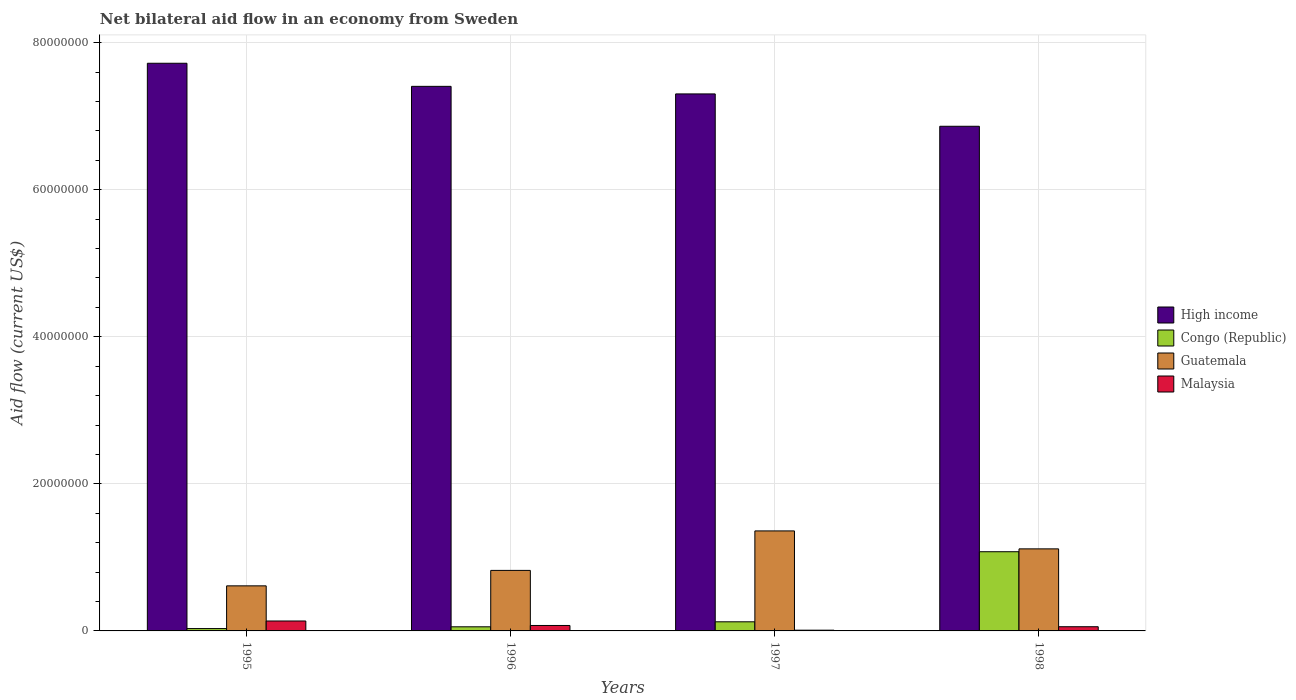Are the number of bars per tick equal to the number of legend labels?
Your answer should be very brief. Yes. Are the number of bars on each tick of the X-axis equal?
Provide a short and direct response. Yes. How many bars are there on the 3rd tick from the right?
Offer a very short reply. 4. What is the label of the 1st group of bars from the left?
Your answer should be compact. 1995. What is the net bilateral aid flow in High income in 1998?
Keep it short and to the point. 6.86e+07. Across all years, what is the maximum net bilateral aid flow in Malaysia?
Give a very brief answer. 1.35e+06. Across all years, what is the minimum net bilateral aid flow in High income?
Keep it short and to the point. 6.86e+07. In which year was the net bilateral aid flow in Congo (Republic) maximum?
Offer a terse response. 1998. In which year was the net bilateral aid flow in High income minimum?
Give a very brief answer. 1998. What is the total net bilateral aid flow in Congo (Republic) in the graph?
Provide a short and direct response. 1.29e+07. What is the difference between the net bilateral aid flow in Congo (Republic) in 1996 and that in 1998?
Make the answer very short. -1.02e+07. What is the difference between the net bilateral aid flow in High income in 1998 and the net bilateral aid flow in Guatemala in 1996?
Your response must be concise. 6.04e+07. What is the average net bilateral aid flow in High income per year?
Offer a very short reply. 7.32e+07. In the year 1995, what is the difference between the net bilateral aid flow in High income and net bilateral aid flow in Guatemala?
Your answer should be compact. 7.11e+07. What is the ratio of the net bilateral aid flow in Malaysia in 1997 to that in 1998?
Provide a short and direct response. 0.18. Is the net bilateral aid flow in Malaysia in 1995 less than that in 1997?
Provide a short and direct response. No. Is the difference between the net bilateral aid flow in High income in 1995 and 1998 greater than the difference between the net bilateral aid flow in Guatemala in 1995 and 1998?
Your answer should be compact. Yes. What is the difference between the highest and the lowest net bilateral aid flow in High income?
Offer a very short reply. 8.57e+06. In how many years, is the net bilateral aid flow in Congo (Republic) greater than the average net bilateral aid flow in Congo (Republic) taken over all years?
Give a very brief answer. 1. Is the sum of the net bilateral aid flow in Guatemala in 1996 and 1997 greater than the maximum net bilateral aid flow in High income across all years?
Offer a very short reply. No. Is it the case that in every year, the sum of the net bilateral aid flow in Malaysia and net bilateral aid flow in High income is greater than the sum of net bilateral aid flow in Congo (Republic) and net bilateral aid flow in Guatemala?
Give a very brief answer. Yes. What does the 1st bar from the left in 1998 represents?
Give a very brief answer. High income. Is it the case that in every year, the sum of the net bilateral aid flow in High income and net bilateral aid flow in Malaysia is greater than the net bilateral aid flow in Guatemala?
Provide a succinct answer. Yes. Are all the bars in the graph horizontal?
Offer a terse response. No. How many years are there in the graph?
Offer a terse response. 4. Are the values on the major ticks of Y-axis written in scientific E-notation?
Offer a very short reply. No. Does the graph contain grids?
Offer a very short reply. Yes. Where does the legend appear in the graph?
Your response must be concise. Center right. How are the legend labels stacked?
Your answer should be compact. Vertical. What is the title of the graph?
Ensure brevity in your answer.  Net bilateral aid flow in an economy from Sweden. What is the label or title of the Y-axis?
Offer a very short reply. Aid flow (current US$). What is the Aid flow (current US$) of High income in 1995?
Give a very brief answer. 7.72e+07. What is the Aid flow (current US$) in Guatemala in 1995?
Your answer should be compact. 6.13e+06. What is the Aid flow (current US$) in Malaysia in 1995?
Your answer should be compact. 1.35e+06. What is the Aid flow (current US$) of High income in 1996?
Your response must be concise. 7.41e+07. What is the Aid flow (current US$) in Congo (Republic) in 1996?
Provide a short and direct response. 5.60e+05. What is the Aid flow (current US$) in Guatemala in 1996?
Make the answer very short. 8.23e+06. What is the Aid flow (current US$) of Malaysia in 1996?
Make the answer very short. 7.40e+05. What is the Aid flow (current US$) in High income in 1997?
Your answer should be compact. 7.30e+07. What is the Aid flow (current US$) of Congo (Republic) in 1997?
Your response must be concise. 1.24e+06. What is the Aid flow (current US$) in Guatemala in 1997?
Keep it short and to the point. 1.36e+07. What is the Aid flow (current US$) in High income in 1998?
Provide a short and direct response. 6.86e+07. What is the Aid flow (current US$) in Congo (Republic) in 1998?
Your response must be concise. 1.08e+07. What is the Aid flow (current US$) of Guatemala in 1998?
Offer a terse response. 1.12e+07. What is the Aid flow (current US$) of Malaysia in 1998?
Provide a succinct answer. 5.70e+05. Across all years, what is the maximum Aid flow (current US$) of High income?
Offer a terse response. 7.72e+07. Across all years, what is the maximum Aid flow (current US$) in Congo (Republic)?
Your answer should be very brief. 1.08e+07. Across all years, what is the maximum Aid flow (current US$) of Guatemala?
Provide a short and direct response. 1.36e+07. Across all years, what is the maximum Aid flow (current US$) in Malaysia?
Your response must be concise. 1.35e+06. Across all years, what is the minimum Aid flow (current US$) in High income?
Your answer should be compact. 6.86e+07. Across all years, what is the minimum Aid flow (current US$) of Congo (Republic)?
Your answer should be very brief. 3.20e+05. Across all years, what is the minimum Aid flow (current US$) of Guatemala?
Make the answer very short. 6.13e+06. What is the total Aid flow (current US$) of High income in the graph?
Provide a succinct answer. 2.93e+08. What is the total Aid flow (current US$) in Congo (Republic) in the graph?
Your response must be concise. 1.29e+07. What is the total Aid flow (current US$) in Guatemala in the graph?
Your answer should be compact. 3.91e+07. What is the total Aid flow (current US$) of Malaysia in the graph?
Your answer should be compact. 2.76e+06. What is the difference between the Aid flow (current US$) in High income in 1995 and that in 1996?
Give a very brief answer. 3.14e+06. What is the difference between the Aid flow (current US$) in Congo (Republic) in 1995 and that in 1996?
Give a very brief answer. -2.40e+05. What is the difference between the Aid flow (current US$) in Guatemala in 1995 and that in 1996?
Your answer should be very brief. -2.10e+06. What is the difference between the Aid flow (current US$) in High income in 1995 and that in 1997?
Give a very brief answer. 4.17e+06. What is the difference between the Aid flow (current US$) of Congo (Republic) in 1995 and that in 1997?
Offer a terse response. -9.20e+05. What is the difference between the Aid flow (current US$) in Guatemala in 1995 and that in 1997?
Provide a short and direct response. -7.47e+06. What is the difference between the Aid flow (current US$) of Malaysia in 1995 and that in 1997?
Your response must be concise. 1.25e+06. What is the difference between the Aid flow (current US$) of High income in 1995 and that in 1998?
Make the answer very short. 8.57e+06. What is the difference between the Aid flow (current US$) of Congo (Republic) in 1995 and that in 1998?
Make the answer very short. -1.04e+07. What is the difference between the Aid flow (current US$) of Guatemala in 1995 and that in 1998?
Offer a terse response. -5.03e+06. What is the difference between the Aid flow (current US$) of Malaysia in 1995 and that in 1998?
Your answer should be very brief. 7.80e+05. What is the difference between the Aid flow (current US$) of High income in 1996 and that in 1997?
Make the answer very short. 1.03e+06. What is the difference between the Aid flow (current US$) of Congo (Republic) in 1996 and that in 1997?
Your response must be concise. -6.80e+05. What is the difference between the Aid flow (current US$) in Guatemala in 1996 and that in 1997?
Your answer should be very brief. -5.37e+06. What is the difference between the Aid flow (current US$) in Malaysia in 1996 and that in 1997?
Provide a short and direct response. 6.40e+05. What is the difference between the Aid flow (current US$) in High income in 1996 and that in 1998?
Your answer should be very brief. 5.43e+06. What is the difference between the Aid flow (current US$) in Congo (Republic) in 1996 and that in 1998?
Give a very brief answer. -1.02e+07. What is the difference between the Aid flow (current US$) in Guatemala in 1996 and that in 1998?
Keep it short and to the point. -2.93e+06. What is the difference between the Aid flow (current US$) in High income in 1997 and that in 1998?
Provide a succinct answer. 4.40e+06. What is the difference between the Aid flow (current US$) of Congo (Republic) in 1997 and that in 1998?
Offer a very short reply. -9.53e+06. What is the difference between the Aid flow (current US$) of Guatemala in 1997 and that in 1998?
Keep it short and to the point. 2.44e+06. What is the difference between the Aid flow (current US$) in Malaysia in 1997 and that in 1998?
Make the answer very short. -4.70e+05. What is the difference between the Aid flow (current US$) in High income in 1995 and the Aid flow (current US$) in Congo (Republic) in 1996?
Your answer should be compact. 7.66e+07. What is the difference between the Aid flow (current US$) of High income in 1995 and the Aid flow (current US$) of Guatemala in 1996?
Offer a very short reply. 6.90e+07. What is the difference between the Aid flow (current US$) of High income in 1995 and the Aid flow (current US$) of Malaysia in 1996?
Provide a succinct answer. 7.65e+07. What is the difference between the Aid flow (current US$) in Congo (Republic) in 1995 and the Aid flow (current US$) in Guatemala in 1996?
Make the answer very short. -7.91e+06. What is the difference between the Aid flow (current US$) in Congo (Republic) in 1995 and the Aid flow (current US$) in Malaysia in 1996?
Give a very brief answer. -4.20e+05. What is the difference between the Aid flow (current US$) of Guatemala in 1995 and the Aid flow (current US$) of Malaysia in 1996?
Give a very brief answer. 5.39e+06. What is the difference between the Aid flow (current US$) in High income in 1995 and the Aid flow (current US$) in Congo (Republic) in 1997?
Your response must be concise. 7.60e+07. What is the difference between the Aid flow (current US$) of High income in 1995 and the Aid flow (current US$) of Guatemala in 1997?
Offer a very short reply. 6.36e+07. What is the difference between the Aid flow (current US$) in High income in 1995 and the Aid flow (current US$) in Malaysia in 1997?
Provide a succinct answer. 7.71e+07. What is the difference between the Aid flow (current US$) in Congo (Republic) in 1995 and the Aid flow (current US$) in Guatemala in 1997?
Your response must be concise. -1.33e+07. What is the difference between the Aid flow (current US$) in Guatemala in 1995 and the Aid flow (current US$) in Malaysia in 1997?
Give a very brief answer. 6.03e+06. What is the difference between the Aid flow (current US$) of High income in 1995 and the Aid flow (current US$) of Congo (Republic) in 1998?
Ensure brevity in your answer.  6.64e+07. What is the difference between the Aid flow (current US$) in High income in 1995 and the Aid flow (current US$) in Guatemala in 1998?
Ensure brevity in your answer.  6.60e+07. What is the difference between the Aid flow (current US$) of High income in 1995 and the Aid flow (current US$) of Malaysia in 1998?
Provide a succinct answer. 7.66e+07. What is the difference between the Aid flow (current US$) of Congo (Republic) in 1995 and the Aid flow (current US$) of Guatemala in 1998?
Ensure brevity in your answer.  -1.08e+07. What is the difference between the Aid flow (current US$) of Guatemala in 1995 and the Aid flow (current US$) of Malaysia in 1998?
Give a very brief answer. 5.56e+06. What is the difference between the Aid flow (current US$) in High income in 1996 and the Aid flow (current US$) in Congo (Republic) in 1997?
Offer a terse response. 7.28e+07. What is the difference between the Aid flow (current US$) of High income in 1996 and the Aid flow (current US$) of Guatemala in 1997?
Ensure brevity in your answer.  6.05e+07. What is the difference between the Aid flow (current US$) of High income in 1996 and the Aid flow (current US$) of Malaysia in 1997?
Make the answer very short. 7.40e+07. What is the difference between the Aid flow (current US$) in Congo (Republic) in 1996 and the Aid flow (current US$) in Guatemala in 1997?
Keep it short and to the point. -1.30e+07. What is the difference between the Aid flow (current US$) of Guatemala in 1996 and the Aid flow (current US$) of Malaysia in 1997?
Offer a terse response. 8.13e+06. What is the difference between the Aid flow (current US$) in High income in 1996 and the Aid flow (current US$) in Congo (Republic) in 1998?
Ensure brevity in your answer.  6.33e+07. What is the difference between the Aid flow (current US$) of High income in 1996 and the Aid flow (current US$) of Guatemala in 1998?
Your answer should be compact. 6.29e+07. What is the difference between the Aid flow (current US$) of High income in 1996 and the Aid flow (current US$) of Malaysia in 1998?
Offer a very short reply. 7.35e+07. What is the difference between the Aid flow (current US$) in Congo (Republic) in 1996 and the Aid flow (current US$) in Guatemala in 1998?
Offer a terse response. -1.06e+07. What is the difference between the Aid flow (current US$) in Congo (Republic) in 1996 and the Aid flow (current US$) in Malaysia in 1998?
Make the answer very short. -10000. What is the difference between the Aid flow (current US$) of Guatemala in 1996 and the Aid flow (current US$) of Malaysia in 1998?
Your answer should be compact. 7.66e+06. What is the difference between the Aid flow (current US$) in High income in 1997 and the Aid flow (current US$) in Congo (Republic) in 1998?
Provide a succinct answer. 6.23e+07. What is the difference between the Aid flow (current US$) of High income in 1997 and the Aid flow (current US$) of Guatemala in 1998?
Make the answer very short. 6.19e+07. What is the difference between the Aid flow (current US$) in High income in 1997 and the Aid flow (current US$) in Malaysia in 1998?
Give a very brief answer. 7.25e+07. What is the difference between the Aid flow (current US$) in Congo (Republic) in 1997 and the Aid flow (current US$) in Guatemala in 1998?
Keep it short and to the point. -9.92e+06. What is the difference between the Aid flow (current US$) of Congo (Republic) in 1997 and the Aid flow (current US$) of Malaysia in 1998?
Your answer should be compact. 6.70e+05. What is the difference between the Aid flow (current US$) of Guatemala in 1997 and the Aid flow (current US$) of Malaysia in 1998?
Give a very brief answer. 1.30e+07. What is the average Aid flow (current US$) of High income per year?
Keep it short and to the point. 7.32e+07. What is the average Aid flow (current US$) in Congo (Republic) per year?
Keep it short and to the point. 3.22e+06. What is the average Aid flow (current US$) of Guatemala per year?
Your answer should be compact. 9.78e+06. What is the average Aid flow (current US$) of Malaysia per year?
Your answer should be compact. 6.90e+05. In the year 1995, what is the difference between the Aid flow (current US$) in High income and Aid flow (current US$) in Congo (Republic)?
Provide a succinct answer. 7.69e+07. In the year 1995, what is the difference between the Aid flow (current US$) in High income and Aid flow (current US$) in Guatemala?
Your answer should be very brief. 7.11e+07. In the year 1995, what is the difference between the Aid flow (current US$) of High income and Aid flow (current US$) of Malaysia?
Your answer should be compact. 7.58e+07. In the year 1995, what is the difference between the Aid flow (current US$) in Congo (Republic) and Aid flow (current US$) in Guatemala?
Give a very brief answer. -5.81e+06. In the year 1995, what is the difference between the Aid flow (current US$) in Congo (Republic) and Aid flow (current US$) in Malaysia?
Make the answer very short. -1.03e+06. In the year 1995, what is the difference between the Aid flow (current US$) in Guatemala and Aid flow (current US$) in Malaysia?
Provide a short and direct response. 4.78e+06. In the year 1996, what is the difference between the Aid flow (current US$) of High income and Aid flow (current US$) of Congo (Republic)?
Provide a short and direct response. 7.35e+07. In the year 1996, what is the difference between the Aid flow (current US$) of High income and Aid flow (current US$) of Guatemala?
Your answer should be very brief. 6.58e+07. In the year 1996, what is the difference between the Aid flow (current US$) of High income and Aid flow (current US$) of Malaysia?
Your answer should be compact. 7.33e+07. In the year 1996, what is the difference between the Aid flow (current US$) of Congo (Republic) and Aid flow (current US$) of Guatemala?
Ensure brevity in your answer.  -7.67e+06. In the year 1996, what is the difference between the Aid flow (current US$) in Congo (Republic) and Aid flow (current US$) in Malaysia?
Offer a very short reply. -1.80e+05. In the year 1996, what is the difference between the Aid flow (current US$) in Guatemala and Aid flow (current US$) in Malaysia?
Give a very brief answer. 7.49e+06. In the year 1997, what is the difference between the Aid flow (current US$) in High income and Aid flow (current US$) in Congo (Republic)?
Ensure brevity in your answer.  7.18e+07. In the year 1997, what is the difference between the Aid flow (current US$) in High income and Aid flow (current US$) in Guatemala?
Ensure brevity in your answer.  5.94e+07. In the year 1997, what is the difference between the Aid flow (current US$) in High income and Aid flow (current US$) in Malaysia?
Ensure brevity in your answer.  7.29e+07. In the year 1997, what is the difference between the Aid flow (current US$) in Congo (Republic) and Aid flow (current US$) in Guatemala?
Provide a succinct answer. -1.24e+07. In the year 1997, what is the difference between the Aid flow (current US$) of Congo (Republic) and Aid flow (current US$) of Malaysia?
Make the answer very short. 1.14e+06. In the year 1997, what is the difference between the Aid flow (current US$) in Guatemala and Aid flow (current US$) in Malaysia?
Give a very brief answer. 1.35e+07. In the year 1998, what is the difference between the Aid flow (current US$) of High income and Aid flow (current US$) of Congo (Republic)?
Offer a very short reply. 5.79e+07. In the year 1998, what is the difference between the Aid flow (current US$) in High income and Aid flow (current US$) in Guatemala?
Offer a terse response. 5.75e+07. In the year 1998, what is the difference between the Aid flow (current US$) of High income and Aid flow (current US$) of Malaysia?
Provide a succinct answer. 6.81e+07. In the year 1998, what is the difference between the Aid flow (current US$) of Congo (Republic) and Aid flow (current US$) of Guatemala?
Your answer should be very brief. -3.90e+05. In the year 1998, what is the difference between the Aid flow (current US$) in Congo (Republic) and Aid flow (current US$) in Malaysia?
Make the answer very short. 1.02e+07. In the year 1998, what is the difference between the Aid flow (current US$) in Guatemala and Aid flow (current US$) in Malaysia?
Offer a terse response. 1.06e+07. What is the ratio of the Aid flow (current US$) of High income in 1995 to that in 1996?
Provide a short and direct response. 1.04. What is the ratio of the Aid flow (current US$) in Guatemala in 1995 to that in 1996?
Keep it short and to the point. 0.74. What is the ratio of the Aid flow (current US$) of Malaysia in 1995 to that in 1996?
Offer a terse response. 1.82. What is the ratio of the Aid flow (current US$) of High income in 1995 to that in 1997?
Offer a very short reply. 1.06. What is the ratio of the Aid flow (current US$) of Congo (Republic) in 1995 to that in 1997?
Your answer should be very brief. 0.26. What is the ratio of the Aid flow (current US$) of Guatemala in 1995 to that in 1997?
Your answer should be compact. 0.45. What is the ratio of the Aid flow (current US$) of High income in 1995 to that in 1998?
Your answer should be very brief. 1.12. What is the ratio of the Aid flow (current US$) of Congo (Republic) in 1995 to that in 1998?
Offer a terse response. 0.03. What is the ratio of the Aid flow (current US$) in Guatemala in 1995 to that in 1998?
Make the answer very short. 0.55. What is the ratio of the Aid flow (current US$) of Malaysia in 1995 to that in 1998?
Your answer should be compact. 2.37. What is the ratio of the Aid flow (current US$) in High income in 1996 to that in 1997?
Ensure brevity in your answer.  1.01. What is the ratio of the Aid flow (current US$) in Congo (Republic) in 1996 to that in 1997?
Offer a very short reply. 0.45. What is the ratio of the Aid flow (current US$) in Guatemala in 1996 to that in 1997?
Give a very brief answer. 0.61. What is the ratio of the Aid flow (current US$) of Malaysia in 1996 to that in 1997?
Offer a very short reply. 7.4. What is the ratio of the Aid flow (current US$) of High income in 1996 to that in 1998?
Keep it short and to the point. 1.08. What is the ratio of the Aid flow (current US$) of Congo (Republic) in 1996 to that in 1998?
Offer a terse response. 0.05. What is the ratio of the Aid flow (current US$) in Guatemala in 1996 to that in 1998?
Your response must be concise. 0.74. What is the ratio of the Aid flow (current US$) in Malaysia in 1996 to that in 1998?
Give a very brief answer. 1.3. What is the ratio of the Aid flow (current US$) of High income in 1997 to that in 1998?
Your answer should be very brief. 1.06. What is the ratio of the Aid flow (current US$) in Congo (Republic) in 1997 to that in 1998?
Provide a succinct answer. 0.12. What is the ratio of the Aid flow (current US$) of Guatemala in 1997 to that in 1998?
Provide a short and direct response. 1.22. What is the ratio of the Aid flow (current US$) of Malaysia in 1997 to that in 1998?
Give a very brief answer. 0.18. What is the difference between the highest and the second highest Aid flow (current US$) of High income?
Your response must be concise. 3.14e+06. What is the difference between the highest and the second highest Aid flow (current US$) in Congo (Republic)?
Ensure brevity in your answer.  9.53e+06. What is the difference between the highest and the second highest Aid flow (current US$) of Guatemala?
Make the answer very short. 2.44e+06. What is the difference between the highest and the second highest Aid flow (current US$) in Malaysia?
Provide a succinct answer. 6.10e+05. What is the difference between the highest and the lowest Aid flow (current US$) in High income?
Give a very brief answer. 8.57e+06. What is the difference between the highest and the lowest Aid flow (current US$) in Congo (Republic)?
Provide a succinct answer. 1.04e+07. What is the difference between the highest and the lowest Aid flow (current US$) of Guatemala?
Provide a succinct answer. 7.47e+06. What is the difference between the highest and the lowest Aid flow (current US$) of Malaysia?
Provide a short and direct response. 1.25e+06. 